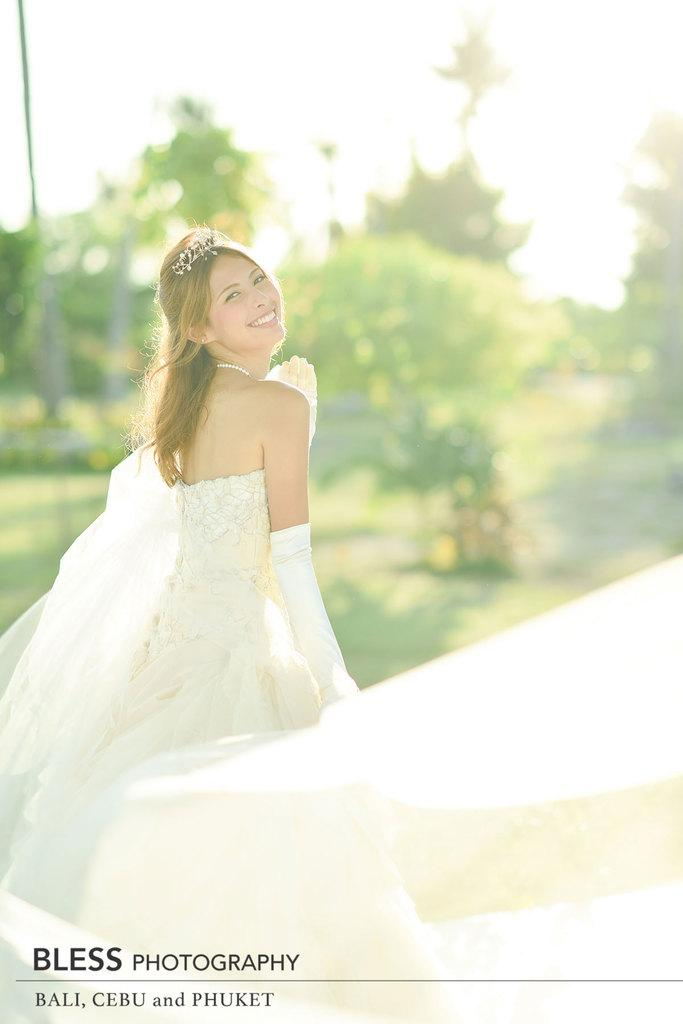Who is present in the image? There is a woman in the image. What is the woman wearing? The woman is wearing a white dress. What expression does the woman have? The woman is smiling. What can be seen in the background of the image? There are trees and a pole in the background of the image. What part of the natural environment is visible in the image? The sky is visible in the image. What type of muscle can be seen flexing in the image? There is no muscle visible in the image; it features a woman wearing a white dress and smiling. What is the woman doing in her bedroom in the image? The image does not show a bedroom, and there is no indication of the woman's activity in the image. 